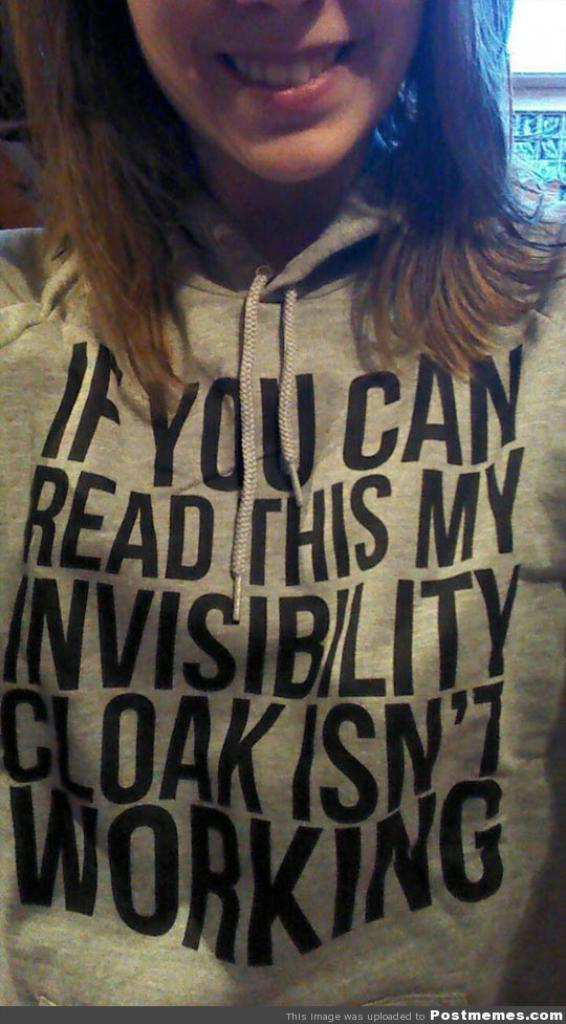What is the main subject of the picture? The main subject of the picture is a woman. Can you describe what the woman is wearing? The woman is wearing a T-shirt. Are there any specific details about the T-shirt? Yes, the T-shirt has text printed on it. Is there any additional information about the image itself? There is a watermark at the bottom of the image. Can you hear the woman whistling in the image? There is no sound in the image, so it is not possible to hear the woman whistling. Is there a carpenter working on a project in the image? There is no carpenter or any indication of construction or destruction in the image. 